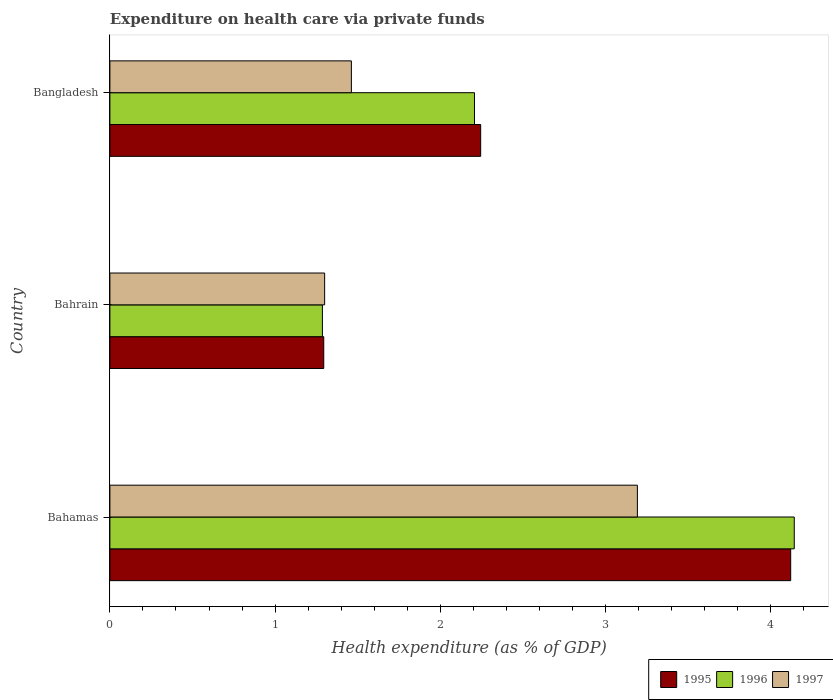How many groups of bars are there?
Keep it short and to the point. 3. Are the number of bars per tick equal to the number of legend labels?
Give a very brief answer. Yes. How many bars are there on the 3rd tick from the top?
Make the answer very short. 3. What is the label of the 3rd group of bars from the top?
Give a very brief answer. Bahamas. What is the expenditure made on health care in 1995 in Bahrain?
Give a very brief answer. 1.29. Across all countries, what is the maximum expenditure made on health care in 1995?
Your answer should be very brief. 4.12. Across all countries, what is the minimum expenditure made on health care in 1996?
Give a very brief answer. 1.29. In which country was the expenditure made on health care in 1996 maximum?
Your answer should be compact. Bahamas. In which country was the expenditure made on health care in 1997 minimum?
Provide a short and direct response. Bahrain. What is the total expenditure made on health care in 1997 in the graph?
Offer a very short reply. 5.95. What is the difference between the expenditure made on health care in 1997 in Bahamas and that in Bangladesh?
Keep it short and to the point. 1.73. What is the difference between the expenditure made on health care in 1995 in Bahamas and the expenditure made on health care in 1996 in Bahrain?
Give a very brief answer. 2.83. What is the average expenditure made on health care in 1995 per country?
Your answer should be compact. 2.55. What is the difference between the expenditure made on health care in 1995 and expenditure made on health care in 1997 in Bahamas?
Your answer should be very brief. 0.93. In how many countries, is the expenditure made on health care in 1996 greater than 2.2 %?
Your response must be concise. 2. What is the ratio of the expenditure made on health care in 1997 in Bahrain to that in Bangladesh?
Your response must be concise. 0.89. Is the difference between the expenditure made on health care in 1995 in Bahrain and Bangladesh greater than the difference between the expenditure made on health care in 1997 in Bahrain and Bangladesh?
Make the answer very short. No. What is the difference between the highest and the second highest expenditure made on health care in 1995?
Make the answer very short. 1.88. What is the difference between the highest and the lowest expenditure made on health care in 1997?
Make the answer very short. 1.89. In how many countries, is the expenditure made on health care in 1995 greater than the average expenditure made on health care in 1995 taken over all countries?
Your response must be concise. 1. What does the 2nd bar from the top in Bahamas represents?
Your response must be concise. 1996. How many bars are there?
Offer a very short reply. 9. Are all the bars in the graph horizontal?
Your response must be concise. Yes. How many countries are there in the graph?
Provide a short and direct response. 3. What is the difference between two consecutive major ticks on the X-axis?
Offer a terse response. 1. Does the graph contain grids?
Give a very brief answer. No. How many legend labels are there?
Keep it short and to the point. 3. How are the legend labels stacked?
Your response must be concise. Horizontal. What is the title of the graph?
Give a very brief answer. Expenditure on health care via private funds. Does "1979" appear as one of the legend labels in the graph?
Offer a very short reply. No. What is the label or title of the X-axis?
Your answer should be compact. Health expenditure (as % of GDP). What is the label or title of the Y-axis?
Your answer should be very brief. Country. What is the Health expenditure (as % of GDP) in 1995 in Bahamas?
Ensure brevity in your answer.  4.12. What is the Health expenditure (as % of GDP) in 1996 in Bahamas?
Your answer should be compact. 4.14. What is the Health expenditure (as % of GDP) of 1997 in Bahamas?
Your answer should be compact. 3.19. What is the Health expenditure (as % of GDP) of 1995 in Bahrain?
Provide a succinct answer. 1.29. What is the Health expenditure (as % of GDP) in 1996 in Bahrain?
Make the answer very short. 1.29. What is the Health expenditure (as % of GDP) of 1997 in Bahrain?
Offer a very short reply. 1.3. What is the Health expenditure (as % of GDP) in 1995 in Bangladesh?
Your answer should be very brief. 2.24. What is the Health expenditure (as % of GDP) of 1996 in Bangladesh?
Make the answer very short. 2.21. What is the Health expenditure (as % of GDP) in 1997 in Bangladesh?
Your response must be concise. 1.46. Across all countries, what is the maximum Health expenditure (as % of GDP) of 1995?
Provide a succinct answer. 4.12. Across all countries, what is the maximum Health expenditure (as % of GDP) of 1996?
Make the answer very short. 4.14. Across all countries, what is the maximum Health expenditure (as % of GDP) of 1997?
Offer a terse response. 3.19. Across all countries, what is the minimum Health expenditure (as % of GDP) in 1995?
Provide a succinct answer. 1.29. Across all countries, what is the minimum Health expenditure (as % of GDP) of 1996?
Give a very brief answer. 1.29. Across all countries, what is the minimum Health expenditure (as % of GDP) of 1997?
Provide a succinct answer. 1.3. What is the total Health expenditure (as % of GDP) of 1995 in the graph?
Provide a succinct answer. 7.66. What is the total Health expenditure (as % of GDP) of 1996 in the graph?
Give a very brief answer. 7.64. What is the total Health expenditure (as % of GDP) of 1997 in the graph?
Your answer should be very brief. 5.95. What is the difference between the Health expenditure (as % of GDP) in 1995 in Bahamas and that in Bahrain?
Offer a terse response. 2.83. What is the difference between the Health expenditure (as % of GDP) in 1996 in Bahamas and that in Bahrain?
Your response must be concise. 2.86. What is the difference between the Health expenditure (as % of GDP) in 1997 in Bahamas and that in Bahrain?
Provide a succinct answer. 1.89. What is the difference between the Health expenditure (as % of GDP) in 1995 in Bahamas and that in Bangladesh?
Provide a succinct answer. 1.88. What is the difference between the Health expenditure (as % of GDP) in 1996 in Bahamas and that in Bangladesh?
Your response must be concise. 1.94. What is the difference between the Health expenditure (as % of GDP) of 1997 in Bahamas and that in Bangladesh?
Keep it short and to the point. 1.73. What is the difference between the Health expenditure (as % of GDP) in 1995 in Bahrain and that in Bangladesh?
Provide a succinct answer. -0.95. What is the difference between the Health expenditure (as % of GDP) in 1996 in Bahrain and that in Bangladesh?
Give a very brief answer. -0.92. What is the difference between the Health expenditure (as % of GDP) of 1997 in Bahrain and that in Bangladesh?
Give a very brief answer. -0.16. What is the difference between the Health expenditure (as % of GDP) in 1995 in Bahamas and the Health expenditure (as % of GDP) in 1996 in Bahrain?
Keep it short and to the point. 2.83. What is the difference between the Health expenditure (as % of GDP) in 1995 in Bahamas and the Health expenditure (as % of GDP) in 1997 in Bahrain?
Provide a short and direct response. 2.82. What is the difference between the Health expenditure (as % of GDP) in 1996 in Bahamas and the Health expenditure (as % of GDP) in 1997 in Bahrain?
Provide a succinct answer. 2.84. What is the difference between the Health expenditure (as % of GDP) in 1995 in Bahamas and the Health expenditure (as % of GDP) in 1996 in Bangladesh?
Your answer should be very brief. 1.91. What is the difference between the Health expenditure (as % of GDP) of 1995 in Bahamas and the Health expenditure (as % of GDP) of 1997 in Bangladesh?
Ensure brevity in your answer.  2.66. What is the difference between the Health expenditure (as % of GDP) of 1996 in Bahamas and the Health expenditure (as % of GDP) of 1997 in Bangladesh?
Your answer should be very brief. 2.68. What is the difference between the Health expenditure (as % of GDP) of 1995 in Bahrain and the Health expenditure (as % of GDP) of 1996 in Bangladesh?
Provide a short and direct response. -0.91. What is the difference between the Health expenditure (as % of GDP) in 1995 in Bahrain and the Health expenditure (as % of GDP) in 1997 in Bangladesh?
Your response must be concise. -0.17. What is the difference between the Health expenditure (as % of GDP) in 1996 in Bahrain and the Health expenditure (as % of GDP) in 1997 in Bangladesh?
Your answer should be compact. -0.18. What is the average Health expenditure (as % of GDP) of 1995 per country?
Give a very brief answer. 2.55. What is the average Health expenditure (as % of GDP) in 1996 per country?
Make the answer very short. 2.55. What is the average Health expenditure (as % of GDP) of 1997 per country?
Your response must be concise. 1.98. What is the difference between the Health expenditure (as % of GDP) in 1995 and Health expenditure (as % of GDP) in 1996 in Bahamas?
Offer a very short reply. -0.02. What is the difference between the Health expenditure (as % of GDP) of 1995 and Health expenditure (as % of GDP) of 1997 in Bahamas?
Give a very brief answer. 0.93. What is the difference between the Health expenditure (as % of GDP) of 1996 and Health expenditure (as % of GDP) of 1997 in Bahamas?
Your response must be concise. 0.95. What is the difference between the Health expenditure (as % of GDP) of 1995 and Health expenditure (as % of GDP) of 1996 in Bahrain?
Ensure brevity in your answer.  0.01. What is the difference between the Health expenditure (as % of GDP) in 1995 and Health expenditure (as % of GDP) in 1997 in Bahrain?
Offer a very short reply. -0.01. What is the difference between the Health expenditure (as % of GDP) in 1996 and Health expenditure (as % of GDP) in 1997 in Bahrain?
Provide a succinct answer. -0.01. What is the difference between the Health expenditure (as % of GDP) in 1995 and Health expenditure (as % of GDP) in 1996 in Bangladesh?
Offer a terse response. 0.04. What is the difference between the Health expenditure (as % of GDP) of 1995 and Health expenditure (as % of GDP) of 1997 in Bangladesh?
Make the answer very short. 0.78. What is the difference between the Health expenditure (as % of GDP) in 1996 and Health expenditure (as % of GDP) in 1997 in Bangladesh?
Offer a very short reply. 0.75. What is the ratio of the Health expenditure (as % of GDP) of 1995 in Bahamas to that in Bahrain?
Keep it short and to the point. 3.18. What is the ratio of the Health expenditure (as % of GDP) of 1996 in Bahamas to that in Bahrain?
Your answer should be very brief. 3.22. What is the ratio of the Health expenditure (as % of GDP) of 1997 in Bahamas to that in Bahrain?
Offer a very short reply. 2.46. What is the ratio of the Health expenditure (as % of GDP) in 1995 in Bahamas to that in Bangladesh?
Give a very brief answer. 1.84. What is the ratio of the Health expenditure (as % of GDP) of 1996 in Bahamas to that in Bangladesh?
Your response must be concise. 1.88. What is the ratio of the Health expenditure (as % of GDP) in 1997 in Bahamas to that in Bangladesh?
Make the answer very short. 2.18. What is the ratio of the Health expenditure (as % of GDP) of 1995 in Bahrain to that in Bangladesh?
Provide a succinct answer. 0.58. What is the ratio of the Health expenditure (as % of GDP) of 1996 in Bahrain to that in Bangladesh?
Your answer should be very brief. 0.58. What is the ratio of the Health expenditure (as % of GDP) in 1997 in Bahrain to that in Bangladesh?
Provide a short and direct response. 0.89. What is the difference between the highest and the second highest Health expenditure (as % of GDP) of 1995?
Ensure brevity in your answer.  1.88. What is the difference between the highest and the second highest Health expenditure (as % of GDP) in 1996?
Ensure brevity in your answer.  1.94. What is the difference between the highest and the second highest Health expenditure (as % of GDP) in 1997?
Ensure brevity in your answer.  1.73. What is the difference between the highest and the lowest Health expenditure (as % of GDP) in 1995?
Ensure brevity in your answer.  2.83. What is the difference between the highest and the lowest Health expenditure (as % of GDP) of 1996?
Offer a terse response. 2.86. What is the difference between the highest and the lowest Health expenditure (as % of GDP) in 1997?
Offer a terse response. 1.89. 